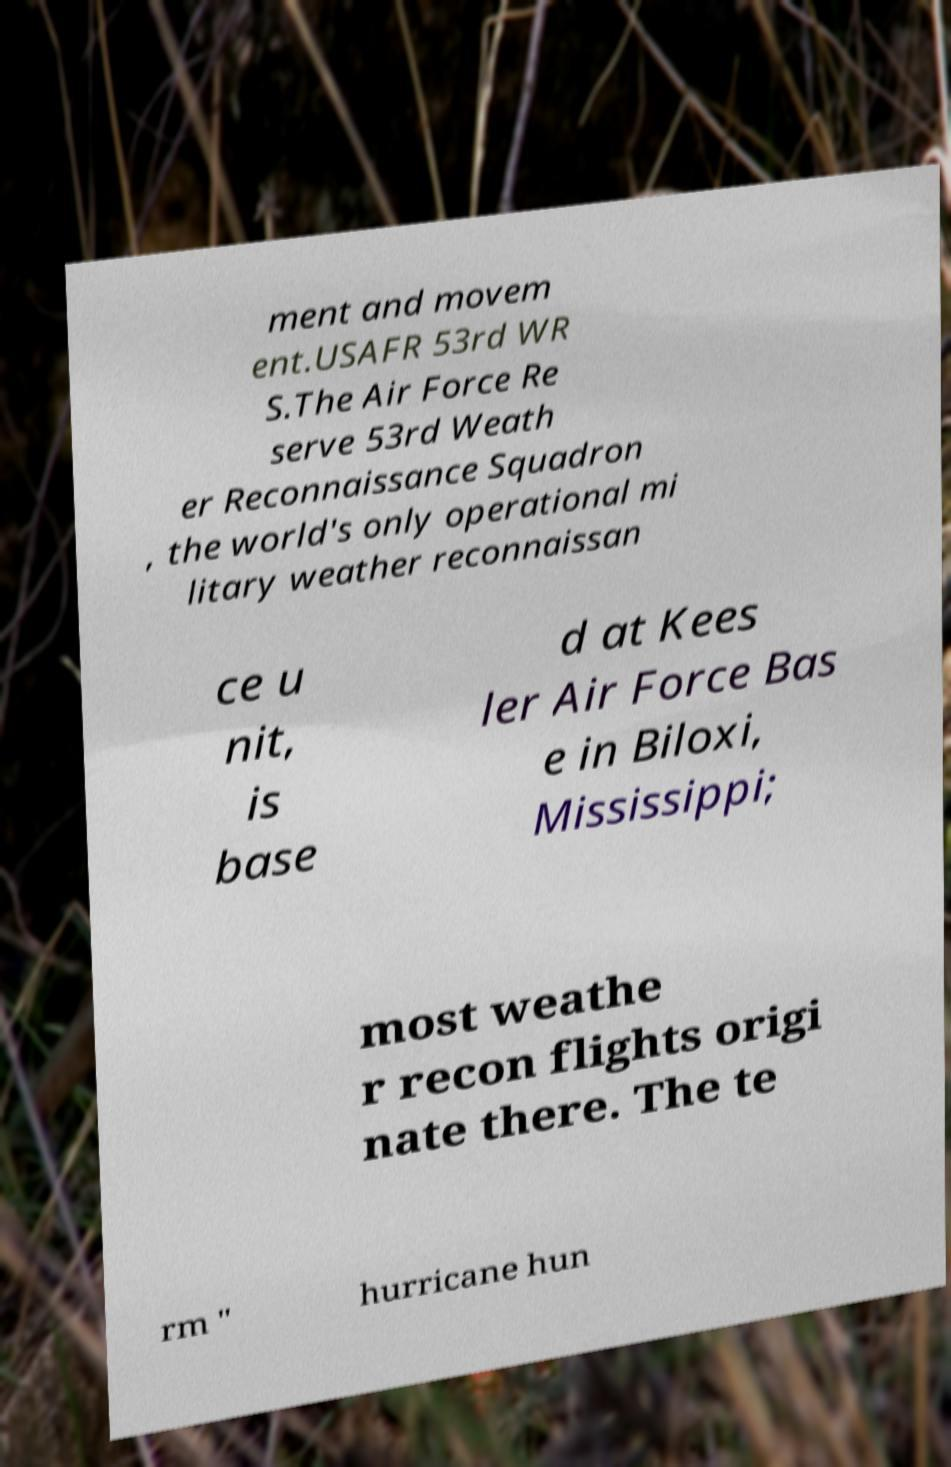For documentation purposes, I need the text within this image transcribed. Could you provide that? ment and movem ent.USAFR 53rd WR S.The Air Force Re serve 53rd Weath er Reconnaissance Squadron , the world's only operational mi litary weather reconnaissan ce u nit, is base d at Kees ler Air Force Bas e in Biloxi, Mississippi; most weathe r recon flights origi nate there. The te rm " hurricane hun 